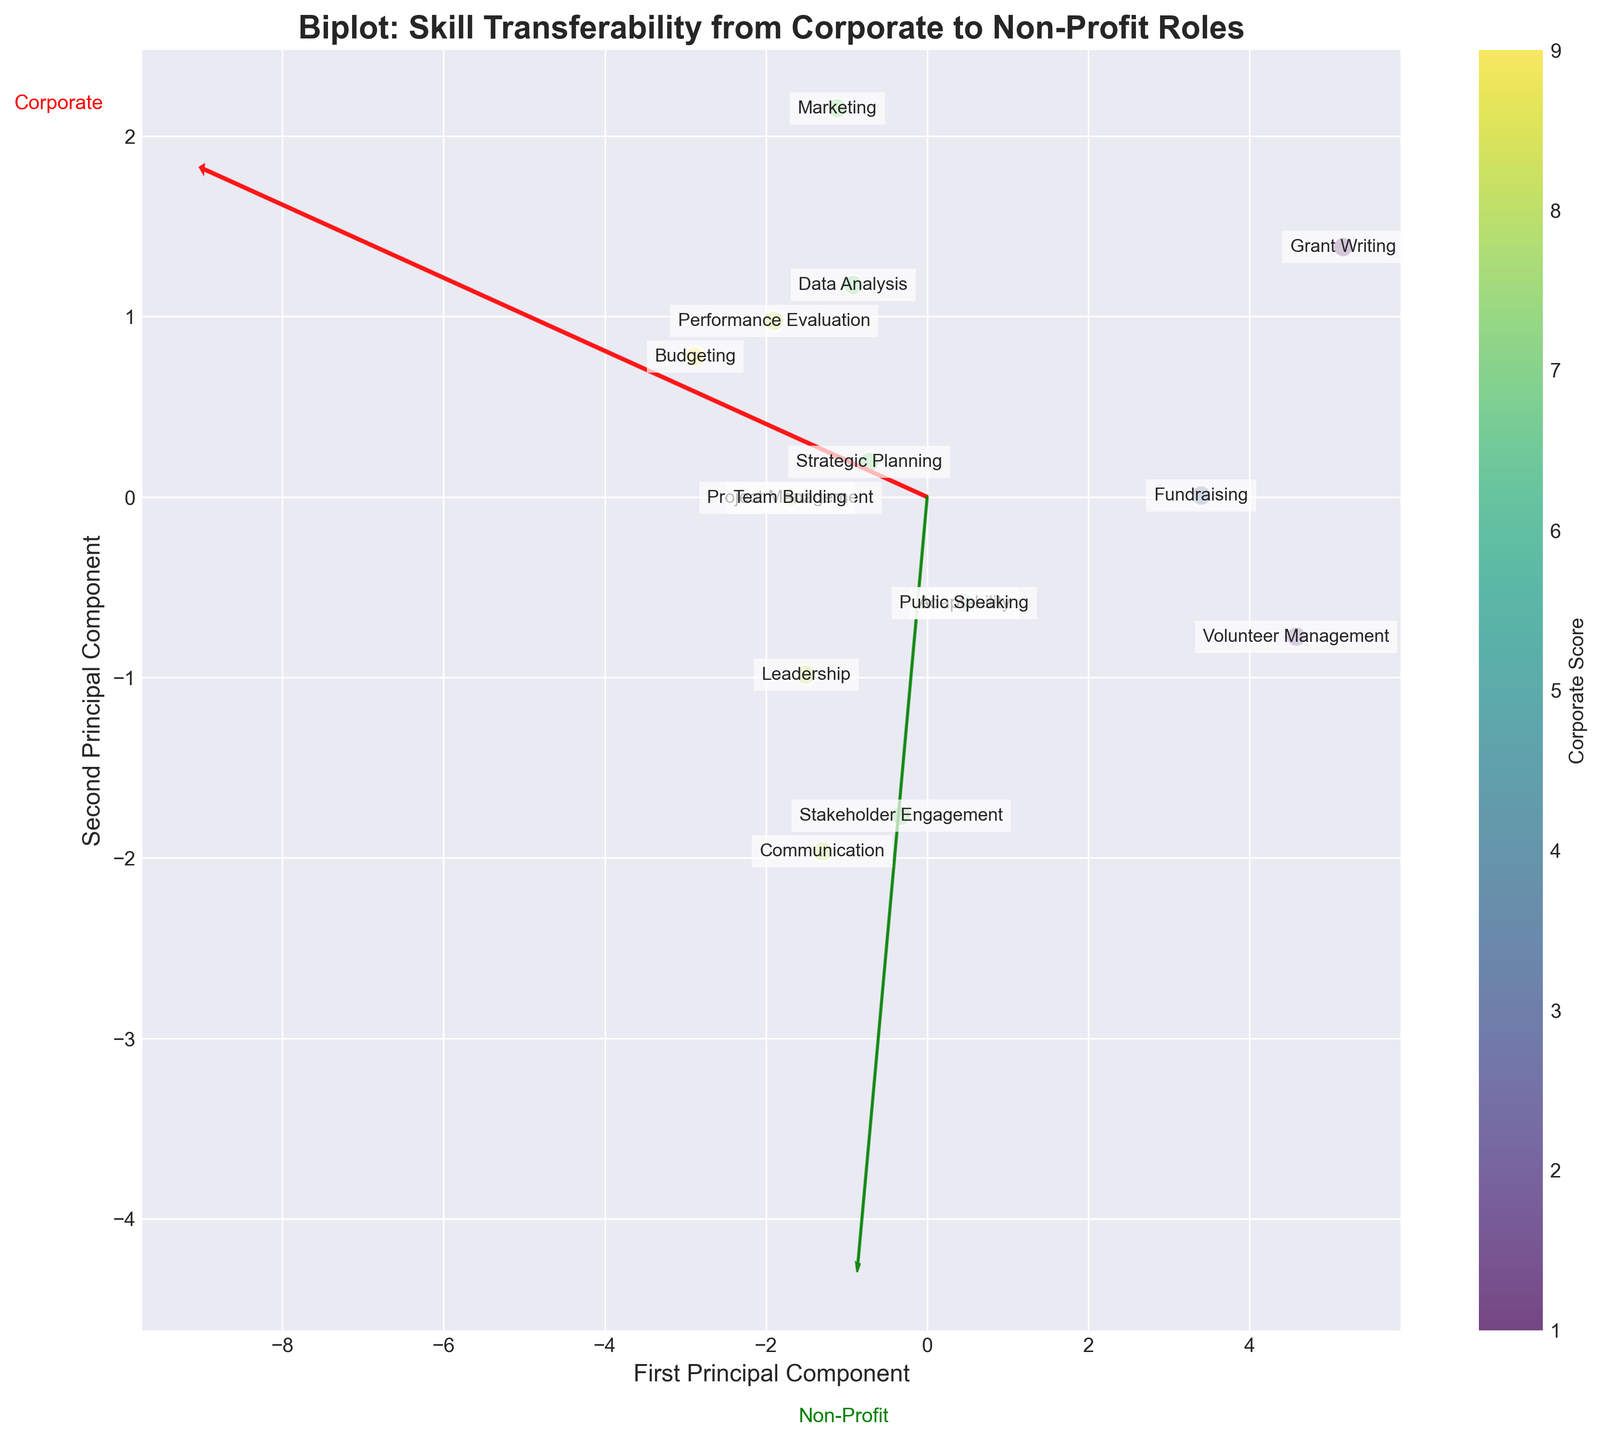How many skills are plotted in the biplot? Count the number of labeled points in the figure
Answer: 15 What is the title of the biplot? Look at the top of the plot where the title is usually located
Answer: Biplot: Skill Transferability from Corporate to Non-Profit Roles Which skill has the highest score in stakeholder engagement? Identify the skill associated with the highest position along the non-profit component arrow in the figure
Answer: Stakeholder Engagement Which skills have equal scores in both corporate and non-profit environments? Locate points where the labels overlap or are very close, indicating equal scores
Answer: Leadership, Strategic Planning Which skill has the lowest corporate score but a high non-profit score? Find the point closest to the origin along the corporate component arrow but high along the non-profit component arrow
Answer: Grant Writing What do the colors of the points represent? Check if there is a color bar or legend in the figure explaining the colors
Answer: Corporate Score Compare the transferability of Project Management and Volunteer Management. Which skill shows more balance between corporate and non-profit roles? Look at the position of these two skills; Project Management should be closer to the origin/balanced center, while Volunteer Management is further along the non-profit component arrow
Answer: Project Management is more balanced Which eigenvector (Corporate or Non-Profit) is more associated with Leadership? Leadership is close to which component arrow, indicating a strong association
Answer: Both, equally associated How do you interpret the distribution of Budgeting and Fundraising in terms of their transferability? Budgeting is strongly aligned with the corporate component; Fundraising is strongly aligned with the non-profit component, indicating they are more transferable to their respective sectors but not across
Answer: Budgeting for corporate, Fundraising for non-profit What can be inferred about the skill Communication based on the plot? Look at Communication's position relative to both component arrows; it's close to the non-profit arrow and similar for corporate, indicating high scores in both but slightly more for non-profit
Answer: High in both, slightly higher in non-profit 